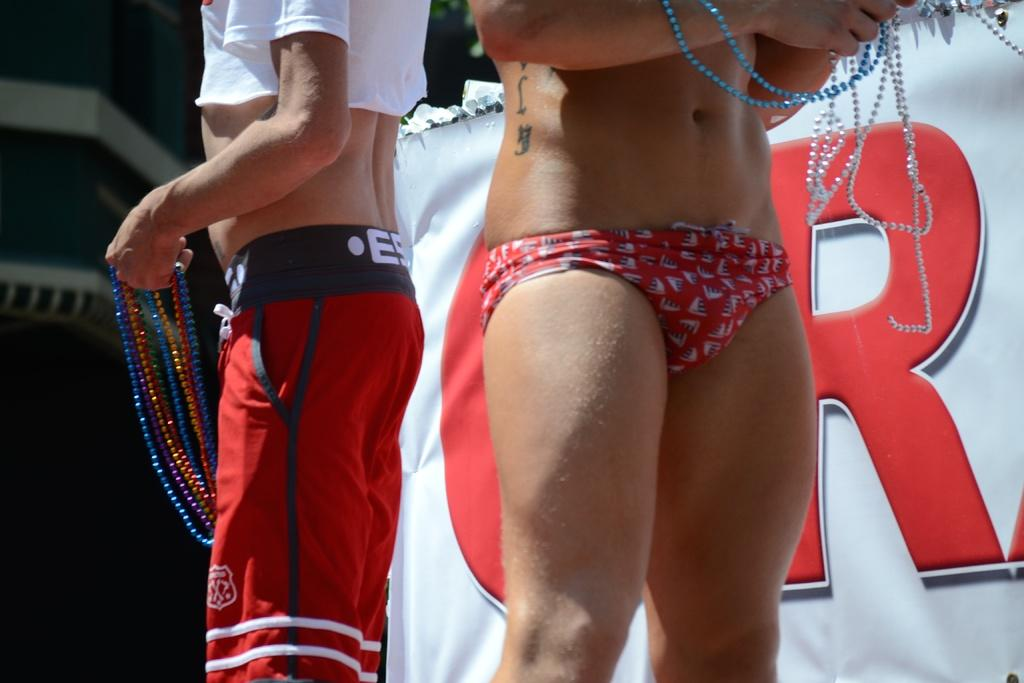<image>
Offer a succinct explanation of the picture presented. Two men in bathing suits hold bead necklaces. 